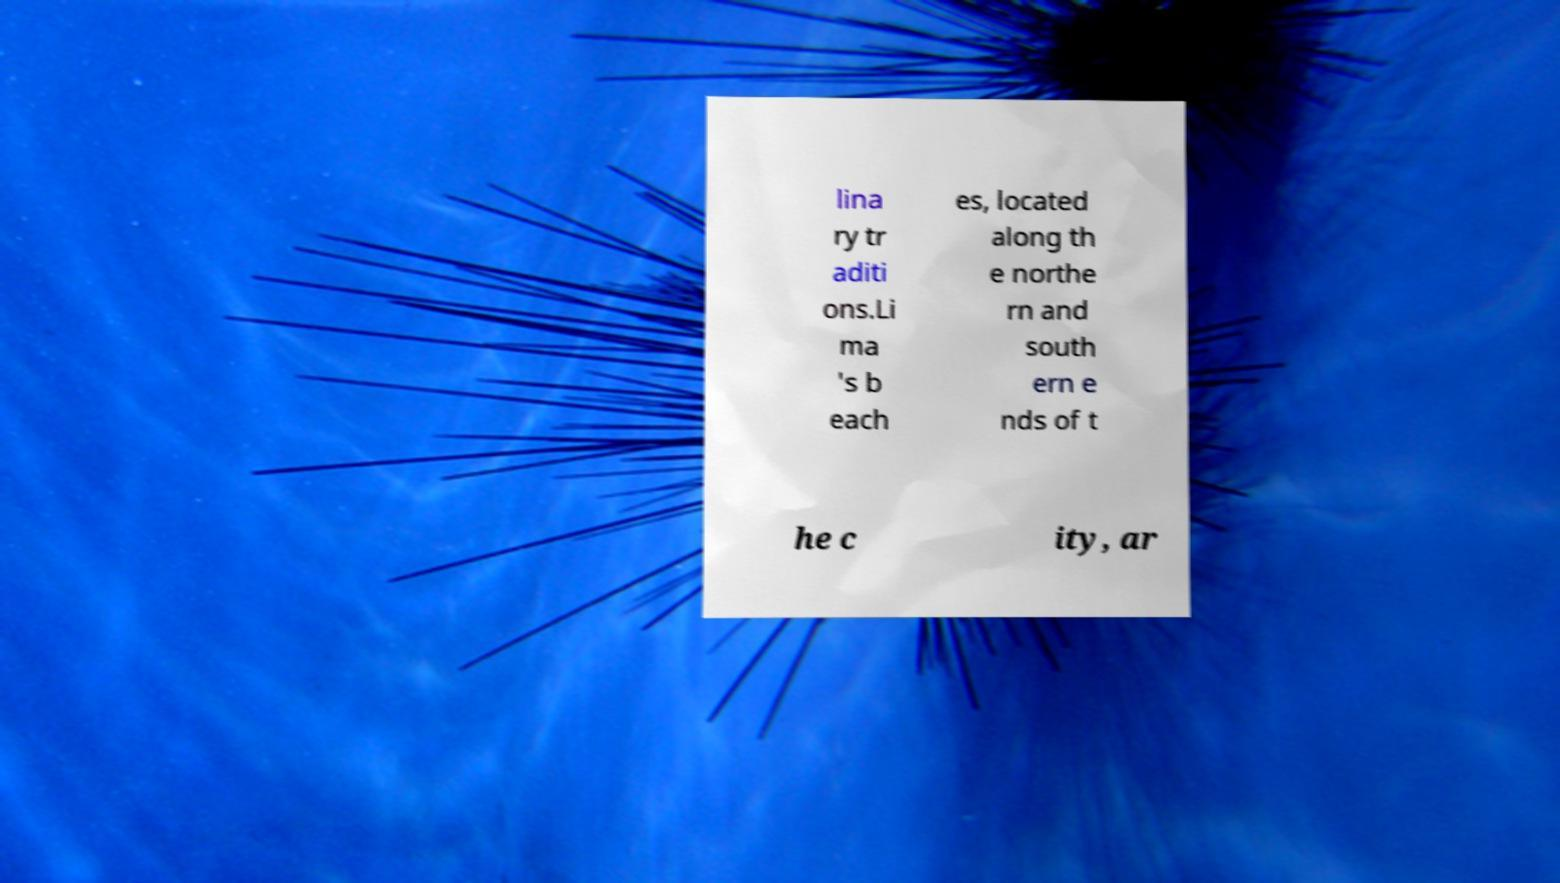Can you read and provide the text displayed in the image?This photo seems to have some interesting text. Can you extract and type it out for me? lina ry tr aditi ons.Li ma 's b each es, located along th e northe rn and south ern e nds of t he c ity, ar 